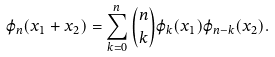<formula> <loc_0><loc_0><loc_500><loc_500>\varphi _ { n } ( x _ { 1 } + x _ { 2 } ) = \sum _ { k = 0 } ^ { n } { n \choose k } \varphi _ { k } ( x _ { 1 } ) \varphi _ { n - k } ( x _ { 2 } ) .</formula> 